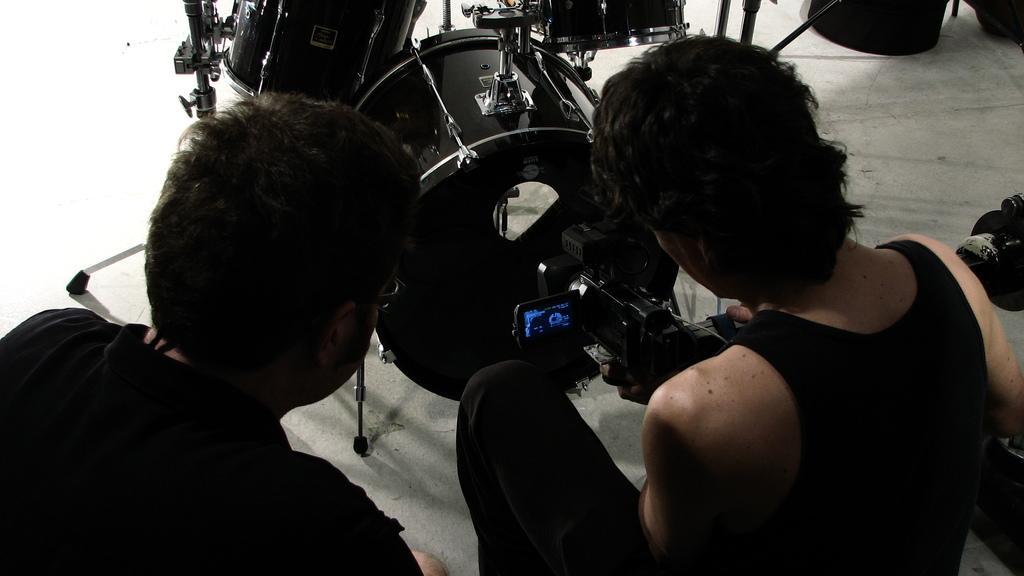In one or two sentences, can you explain what this image depicts? There are two people. Person on the right is holding a camera. In the back there is a musical instrument. 